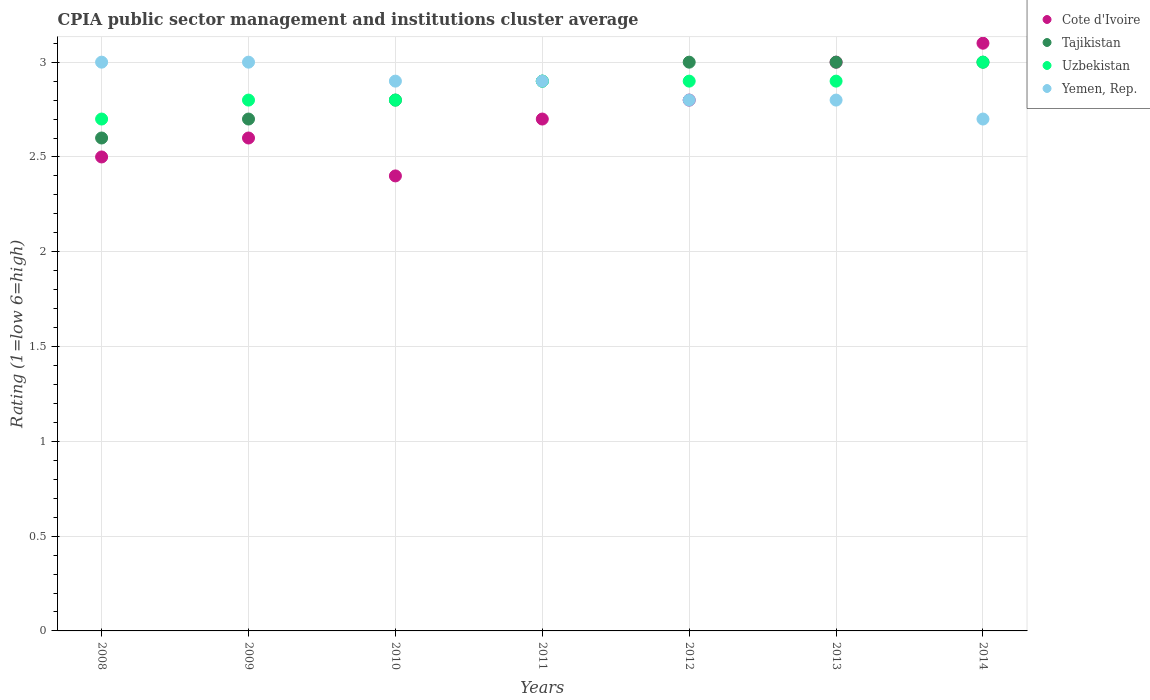How many different coloured dotlines are there?
Your answer should be compact. 4. What is the total CPIA rating in Cote d'Ivoire in the graph?
Provide a succinct answer. 19.1. What is the difference between the CPIA rating in Cote d'Ivoire in 2010 and that in 2013?
Your answer should be very brief. -0.6. What is the difference between the CPIA rating in Cote d'Ivoire in 2008 and the CPIA rating in Uzbekistan in 2010?
Your answer should be very brief. -0.3. What is the average CPIA rating in Uzbekistan per year?
Provide a succinct answer. 2.86. In the year 2010, what is the difference between the CPIA rating in Yemen, Rep. and CPIA rating in Tajikistan?
Your answer should be very brief. 0.1. In how many years, is the CPIA rating in Cote d'Ivoire greater than 1.1?
Provide a succinct answer. 7. What is the ratio of the CPIA rating in Tajikistan in 2008 to that in 2014?
Your response must be concise. 0.87. Is the difference between the CPIA rating in Yemen, Rep. in 2011 and 2012 greater than the difference between the CPIA rating in Tajikistan in 2011 and 2012?
Keep it short and to the point. Yes. What is the difference between the highest and the lowest CPIA rating in Uzbekistan?
Ensure brevity in your answer.  0.3. Is it the case that in every year, the sum of the CPIA rating in Tajikistan and CPIA rating in Yemen, Rep.  is greater than the sum of CPIA rating in Cote d'Ivoire and CPIA rating in Uzbekistan?
Ensure brevity in your answer.  No. Does the CPIA rating in Cote d'Ivoire monotonically increase over the years?
Ensure brevity in your answer.  No. Are the values on the major ticks of Y-axis written in scientific E-notation?
Provide a short and direct response. No. Does the graph contain grids?
Offer a terse response. Yes. How many legend labels are there?
Keep it short and to the point. 4. How are the legend labels stacked?
Provide a succinct answer. Vertical. What is the title of the graph?
Ensure brevity in your answer.  CPIA public sector management and institutions cluster average. What is the label or title of the X-axis?
Keep it short and to the point. Years. What is the label or title of the Y-axis?
Provide a short and direct response. Rating (1=low 6=high). What is the Rating (1=low 6=high) in Tajikistan in 2008?
Your answer should be compact. 2.6. What is the Rating (1=low 6=high) of Uzbekistan in 2008?
Keep it short and to the point. 2.7. What is the Rating (1=low 6=high) of Yemen, Rep. in 2008?
Give a very brief answer. 3. What is the Rating (1=low 6=high) in Tajikistan in 2009?
Provide a succinct answer. 2.7. What is the Rating (1=low 6=high) in Uzbekistan in 2009?
Keep it short and to the point. 2.8. What is the Rating (1=low 6=high) of Cote d'Ivoire in 2010?
Offer a terse response. 2.4. What is the Rating (1=low 6=high) in Uzbekistan in 2010?
Your answer should be compact. 2.8. What is the Rating (1=low 6=high) of Yemen, Rep. in 2010?
Your answer should be very brief. 2.9. What is the Rating (1=low 6=high) of Tajikistan in 2011?
Your answer should be very brief. 2.9. What is the Rating (1=low 6=high) of Uzbekistan in 2011?
Your answer should be very brief. 2.9. What is the Rating (1=low 6=high) in Yemen, Rep. in 2011?
Give a very brief answer. 2.9. What is the Rating (1=low 6=high) in Cote d'Ivoire in 2013?
Your response must be concise. 3. What is the Rating (1=low 6=high) in Uzbekistan in 2013?
Offer a very short reply. 2.9. What is the Rating (1=low 6=high) in Cote d'Ivoire in 2014?
Make the answer very short. 3.1. What is the Rating (1=low 6=high) in Tajikistan in 2014?
Keep it short and to the point. 3. What is the Rating (1=low 6=high) in Uzbekistan in 2014?
Your answer should be very brief. 3. Across all years, what is the maximum Rating (1=low 6=high) in Uzbekistan?
Ensure brevity in your answer.  3. What is the total Rating (1=low 6=high) in Tajikistan in the graph?
Give a very brief answer. 20. What is the total Rating (1=low 6=high) of Uzbekistan in the graph?
Ensure brevity in your answer.  20. What is the total Rating (1=low 6=high) in Yemen, Rep. in the graph?
Make the answer very short. 20.1. What is the difference between the Rating (1=low 6=high) of Tajikistan in 2008 and that in 2009?
Make the answer very short. -0.1. What is the difference between the Rating (1=low 6=high) in Uzbekistan in 2008 and that in 2009?
Make the answer very short. -0.1. What is the difference between the Rating (1=low 6=high) in Yemen, Rep. in 2008 and that in 2009?
Give a very brief answer. 0. What is the difference between the Rating (1=low 6=high) of Cote d'Ivoire in 2008 and that in 2010?
Your answer should be very brief. 0.1. What is the difference between the Rating (1=low 6=high) of Uzbekistan in 2008 and that in 2010?
Provide a short and direct response. -0.1. What is the difference between the Rating (1=low 6=high) in Tajikistan in 2008 and that in 2011?
Provide a succinct answer. -0.3. What is the difference between the Rating (1=low 6=high) in Yemen, Rep. in 2008 and that in 2011?
Your answer should be very brief. 0.1. What is the difference between the Rating (1=low 6=high) in Cote d'Ivoire in 2008 and that in 2012?
Offer a terse response. -0.3. What is the difference between the Rating (1=low 6=high) in Tajikistan in 2008 and that in 2012?
Provide a succinct answer. -0.4. What is the difference between the Rating (1=low 6=high) of Uzbekistan in 2008 and that in 2012?
Keep it short and to the point. -0.2. What is the difference between the Rating (1=low 6=high) in Yemen, Rep. in 2008 and that in 2012?
Provide a succinct answer. 0.2. What is the difference between the Rating (1=low 6=high) in Cote d'Ivoire in 2008 and that in 2013?
Keep it short and to the point. -0.5. What is the difference between the Rating (1=low 6=high) of Uzbekistan in 2008 and that in 2013?
Offer a very short reply. -0.2. What is the difference between the Rating (1=low 6=high) of Yemen, Rep. in 2008 and that in 2013?
Your answer should be very brief. 0.2. What is the difference between the Rating (1=low 6=high) of Uzbekistan in 2008 and that in 2014?
Provide a succinct answer. -0.3. What is the difference between the Rating (1=low 6=high) of Yemen, Rep. in 2008 and that in 2014?
Provide a succinct answer. 0.3. What is the difference between the Rating (1=low 6=high) in Uzbekistan in 2009 and that in 2011?
Your answer should be very brief. -0.1. What is the difference between the Rating (1=low 6=high) in Yemen, Rep. in 2009 and that in 2011?
Keep it short and to the point. 0.1. What is the difference between the Rating (1=low 6=high) in Tajikistan in 2009 and that in 2012?
Your answer should be very brief. -0.3. What is the difference between the Rating (1=low 6=high) of Cote d'Ivoire in 2009 and that in 2014?
Provide a short and direct response. -0.5. What is the difference between the Rating (1=low 6=high) of Uzbekistan in 2009 and that in 2014?
Provide a short and direct response. -0.2. What is the difference between the Rating (1=low 6=high) of Tajikistan in 2010 and that in 2011?
Keep it short and to the point. -0.1. What is the difference between the Rating (1=low 6=high) in Yemen, Rep. in 2010 and that in 2011?
Offer a terse response. 0. What is the difference between the Rating (1=low 6=high) in Cote d'Ivoire in 2010 and that in 2012?
Your answer should be very brief. -0.4. What is the difference between the Rating (1=low 6=high) in Uzbekistan in 2010 and that in 2012?
Provide a succinct answer. -0.1. What is the difference between the Rating (1=low 6=high) of Uzbekistan in 2010 and that in 2013?
Your answer should be compact. -0.1. What is the difference between the Rating (1=low 6=high) of Yemen, Rep. in 2010 and that in 2013?
Give a very brief answer. 0.1. What is the difference between the Rating (1=low 6=high) in Cote d'Ivoire in 2010 and that in 2014?
Your answer should be very brief. -0.7. What is the difference between the Rating (1=low 6=high) of Tajikistan in 2010 and that in 2014?
Your response must be concise. -0.2. What is the difference between the Rating (1=low 6=high) of Uzbekistan in 2010 and that in 2014?
Make the answer very short. -0.2. What is the difference between the Rating (1=low 6=high) in Yemen, Rep. in 2010 and that in 2014?
Your response must be concise. 0.2. What is the difference between the Rating (1=low 6=high) in Cote d'Ivoire in 2011 and that in 2012?
Your answer should be compact. -0.1. What is the difference between the Rating (1=low 6=high) in Tajikistan in 2011 and that in 2012?
Offer a terse response. -0.1. What is the difference between the Rating (1=low 6=high) of Uzbekistan in 2011 and that in 2012?
Give a very brief answer. 0. What is the difference between the Rating (1=low 6=high) in Yemen, Rep. in 2011 and that in 2012?
Your answer should be compact. 0.1. What is the difference between the Rating (1=low 6=high) of Uzbekistan in 2011 and that in 2013?
Your answer should be compact. 0. What is the difference between the Rating (1=low 6=high) of Yemen, Rep. in 2011 and that in 2013?
Provide a succinct answer. 0.1. What is the difference between the Rating (1=low 6=high) of Tajikistan in 2011 and that in 2014?
Provide a short and direct response. -0.1. What is the difference between the Rating (1=low 6=high) of Uzbekistan in 2011 and that in 2014?
Your response must be concise. -0.1. What is the difference between the Rating (1=low 6=high) of Yemen, Rep. in 2011 and that in 2014?
Ensure brevity in your answer.  0.2. What is the difference between the Rating (1=low 6=high) of Yemen, Rep. in 2012 and that in 2013?
Make the answer very short. 0. What is the difference between the Rating (1=low 6=high) in Yemen, Rep. in 2012 and that in 2014?
Your answer should be very brief. 0.1. What is the difference between the Rating (1=low 6=high) in Yemen, Rep. in 2013 and that in 2014?
Make the answer very short. 0.1. What is the difference between the Rating (1=low 6=high) in Cote d'Ivoire in 2008 and the Rating (1=low 6=high) in Uzbekistan in 2009?
Ensure brevity in your answer.  -0.3. What is the difference between the Rating (1=low 6=high) in Cote d'Ivoire in 2008 and the Rating (1=low 6=high) in Yemen, Rep. in 2009?
Your answer should be compact. -0.5. What is the difference between the Rating (1=low 6=high) of Tajikistan in 2008 and the Rating (1=low 6=high) of Uzbekistan in 2009?
Offer a terse response. -0.2. What is the difference between the Rating (1=low 6=high) in Cote d'Ivoire in 2008 and the Rating (1=low 6=high) in Uzbekistan in 2010?
Provide a short and direct response. -0.3. What is the difference between the Rating (1=low 6=high) in Tajikistan in 2008 and the Rating (1=low 6=high) in Uzbekistan in 2010?
Ensure brevity in your answer.  -0.2. What is the difference between the Rating (1=low 6=high) in Uzbekistan in 2008 and the Rating (1=low 6=high) in Yemen, Rep. in 2010?
Your response must be concise. -0.2. What is the difference between the Rating (1=low 6=high) in Cote d'Ivoire in 2008 and the Rating (1=low 6=high) in Yemen, Rep. in 2011?
Your answer should be very brief. -0.4. What is the difference between the Rating (1=low 6=high) in Tajikistan in 2008 and the Rating (1=low 6=high) in Yemen, Rep. in 2011?
Ensure brevity in your answer.  -0.3. What is the difference between the Rating (1=low 6=high) in Uzbekistan in 2008 and the Rating (1=low 6=high) in Yemen, Rep. in 2011?
Offer a very short reply. -0.2. What is the difference between the Rating (1=low 6=high) of Tajikistan in 2008 and the Rating (1=low 6=high) of Uzbekistan in 2012?
Your answer should be compact. -0.3. What is the difference between the Rating (1=low 6=high) of Tajikistan in 2008 and the Rating (1=low 6=high) of Yemen, Rep. in 2012?
Your response must be concise. -0.2. What is the difference between the Rating (1=low 6=high) of Cote d'Ivoire in 2008 and the Rating (1=low 6=high) of Uzbekistan in 2013?
Your answer should be very brief. -0.4. What is the difference between the Rating (1=low 6=high) of Cote d'Ivoire in 2008 and the Rating (1=low 6=high) of Yemen, Rep. in 2013?
Keep it short and to the point. -0.3. What is the difference between the Rating (1=low 6=high) in Tajikistan in 2008 and the Rating (1=low 6=high) in Uzbekistan in 2013?
Give a very brief answer. -0.3. What is the difference between the Rating (1=low 6=high) in Uzbekistan in 2008 and the Rating (1=low 6=high) in Yemen, Rep. in 2013?
Ensure brevity in your answer.  -0.1. What is the difference between the Rating (1=low 6=high) of Tajikistan in 2008 and the Rating (1=low 6=high) of Uzbekistan in 2014?
Offer a very short reply. -0.4. What is the difference between the Rating (1=low 6=high) of Tajikistan in 2008 and the Rating (1=low 6=high) of Yemen, Rep. in 2014?
Provide a short and direct response. -0.1. What is the difference between the Rating (1=low 6=high) of Cote d'Ivoire in 2009 and the Rating (1=low 6=high) of Uzbekistan in 2010?
Ensure brevity in your answer.  -0.2. What is the difference between the Rating (1=low 6=high) in Tajikistan in 2009 and the Rating (1=low 6=high) in Uzbekistan in 2010?
Your answer should be compact. -0.1. What is the difference between the Rating (1=low 6=high) in Cote d'Ivoire in 2009 and the Rating (1=low 6=high) in Uzbekistan in 2011?
Your response must be concise. -0.3. What is the difference between the Rating (1=low 6=high) in Tajikistan in 2009 and the Rating (1=low 6=high) in Uzbekistan in 2011?
Provide a succinct answer. -0.2. What is the difference between the Rating (1=low 6=high) of Cote d'Ivoire in 2009 and the Rating (1=low 6=high) of Tajikistan in 2012?
Ensure brevity in your answer.  -0.4. What is the difference between the Rating (1=low 6=high) of Cote d'Ivoire in 2009 and the Rating (1=low 6=high) of Yemen, Rep. in 2012?
Ensure brevity in your answer.  -0.2. What is the difference between the Rating (1=low 6=high) in Uzbekistan in 2009 and the Rating (1=low 6=high) in Yemen, Rep. in 2012?
Keep it short and to the point. 0. What is the difference between the Rating (1=low 6=high) of Cote d'Ivoire in 2009 and the Rating (1=low 6=high) of Yemen, Rep. in 2013?
Offer a very short reply. -0.2. What is the difference between the Rating (1=low 6=high) of Tajikistan in 2009 and the Rating (1=low 6=high) of Yemen, Rep. in 2013?
Make the answer very short. -0.1. What is the difference between the Rating (1=low 6=high) of Uzbekistan in 2009 and the Rating (1=low 6=high) of Yemen, Rep. in 2013?
Give a very brief answer. 0. What is the difference between the Rating (1=low 6=high) in Tajikistan in 2009 and the Rating (1=low 6=high) in Yemen, Rep. in 2014?
Make the answer very short. 0. What is the difference between the Rating (1=low 6=high) in Uzbekistan in 2009 and the Rating (1=low 6=high) in Yemen, Rep. in 2014?
Give a very brief answer. 0.1. What is the difference between the Rating (1=low 6=high) in Cote d'Ivoire in 2010 and the Rating (1=low 6=high) in Yemen, Rep. in 2011?
Keep it short and to the point. -0.5. What is the difference between the Rating (1=low 6=high) of Tajikistan in 2010 and the Rating (1=low 6=high) of Uzbekistan in 2011?
Your answer should be very brief. -0.1. What is the difference between the Rating (1=low 6=high) of Tajikistan in 2010 and the Rating (1=low 6=high) of Yemen, Rep. in 2011?
Offer a very short reply. -0.1. What is the difference between the Rating (1=low 6=high) in Cote d'Ivoire in 2010 and the Rating (1=low 6=high) in Tajikistan in 2012?
Offer a terse response. -0.6. What is the difference between the Rating (1=low 6=high) of Cote d'Ivoire in 2010 and the Rating (1=low 6=high) of Yemen, Rep. in 2012?
Your answer should be compact. -0.4. What is the difference between the Rating (1=low 6=high) in Tajikistan in 2010 and the Rating (1=low 6=high) in Yemen, Rep. in 2012?
Provide a succinct answer. 0. What is the difference between the Rating (1=low 6=high) of Cote d'Ivoire in 2010 and the Rating (1=low 6=high) of Uzbekistan in 2013?
Keep it short and to the point. -0.5. What is the difference between the Rating (1=low 6=high) in Cote d'Ivoire in 2010 and the Rating (1=low 6=high) in Yemen, Rep. in 2013?
Ensure brevity in your answer.  -0.4. What is the difference between the Rating (1=low 6=high) of Tajikistan in 2010 and the Rating (1=low 6=high) of Uzbekistan in 2013?
Offer a terse response. -0.1. What is the difference between the Rating (1=low 6=high) of Cote d'Ivoire in 2010 and the Rating (1=low 6=high) of Uzbekistan in 2014?
Your response must be concise. -0.6. What is the difference between the Rating (1=low 6=high) in Cote d'Ivoire in 2010 and the Rating (1=low 6=high) in Yemen, Rep. in 2014?
Provide a short and direct response. -0.3. What is the difference between the Rating (1=low 6=high) in Uzbekistan in 2010 and the Rating (1=low 6=high) in Yemen, Rep. in 2014?
Provide a short and direct response. 0.1. What is the difference between the Rating (1=low 6=high) in Cote d'Ivoire in 2011 and the Rating (1=low 6=high) in Tajikistan in 2012?
Your response must be concise. -0.3. What is the difference between the Rating (1=low 6=high) of Cote d'Ivoire in 2011 and the Rating (1=low 6=high) of Uzbekistan in 2012?
Your response must be concise. -0.2. What is the difference between the Rating (1=low 6=high) in Cote d'Ivoire in 2011 and the Rating (1=low 6=high) in Yemen, Rep. in 2012?
Provide a succinct answer. -0.1. What is the difference between the Rating (1=low 6=high) of Tajikistan in 2011 and the Rating (1=low 6=high) of Yemen, Rep. in 2012?
Your response must be concise. 0.1. What is the difference between the Rating (1=low 6=high) of Cote d'Ivoire in 2011 and the Rating (1=low 6=high) of Tajikistan in 2013?
Provide a succinct answer. -0.3. What is the difference between the Rating (1=low 6=high) in Cote d'Ivoire in 2011 and the Rating (1=low 6=high) in Uzbekistan in 2013?
Your answer should be compact. -0.2. What is the difference between the Rating (1=low 6=high) of Cote d'Ivoire in 2011 and the Rating (1=low 6=high) of Yemen, Rep. in 2013?
Your response must be concise. -0.1. What is the difference between the Rating (1=low 6=high) of Tajikistan in 2011 and the Rating (1=low 6=high) of Yemen, Rep. in 2013?
Ensure brevity in your answer.  0.1. What is the difference between the Rating (1=low 6=high) of Uzbekistan in 2011 and the Rating (1=low 6=high) of Yemen, Rep. in 2013?
Give a very brief answer. 0.1. What is the difference between the Rating (1=low 6=high) in Cote d'Ivoire in 2011 and the Rating (1=low 6=high) in Tajikistan in 2014?
Make the answer very short. -0.3. What is the difference between the Rating (1=low 6=high) of Cote d'Ivoire in 2011 and the Rating (1=low 6=high) of Uzbekistan in 2014?
Provide a succinct answer. -0.3. What is the difference between the Rating (1=low 6=high) of Uzbekistan in 2011 and the Rating (1=low 6=high) of Yemen, Rep. in 2014?
Offer a very short reply. 0.2. What is the difference between the Rating (1=low 6=high) of Cote d'Ivoire in 2012 and the Rating (1=low 6=high) of Tajikistan in 2013?
Offer a very short reply. -0.2. What is the difference between the Rating (1=low 6=high) of Cote d'Ivoire in 2012 and the Rating (1=low 6=high) of Uzbekistan in 2013?
Give a very brief answer. -0.1. What is the difference between the Rating (1=low 6=high) in Uzbekistan in 2012 and the Rating (1=low 6=high) in Yemen, Rep. in 2013?
Your response must be concise. 0.1. What is the difference between the Rating (1=low 6=high) of Cote d'Ivoire in 2012 and the Rating (1=low 6=high) of Uzbekistan in 2014?
Provide a succinct answer. -0.2. What is the difference between the Rating (1=low 6=high) in Cote d'Ivoire in 2012 and the Rating (1=low 6=high) in Yemen, Rep. in 2014?
Offer a very short reply. 0.1. What is the difference between the Rating (1=low 6=high) of Tajikistan in 2012 and the Rating (1=low 6=high) of Yemen, Rep. in 2014?
Your response must be concise. 0.3. What is the difference between the Rating (1=low 6=high) in Uzbekistan in 2012 and the Rating (1=low 6=high) in Yemen, Rep. in 2014?
Your answer should be very brief. 0.2. What is the difference between the Rating (1=low 6=high) in Tajikistan in 2013 and the Rating (1=low 6=high) in Yemen, Rep. in 2014?
Make the answer very short. 0.3. What is the average Rating (1=low 6=high) of Cote d'Ivoire per year?
Your answer should be very brief. 2.73. What is the average Rating (1=low 6=high) in Tajikistan per year?
Your response must be concise. 2.86. What is the average Rating (1=low 6=high) in Uzbekistan per year?
Keep it short and to the point. 2.86. What is the average Rating (1=low 6=high) of Yemen, Rep. per year?
Offer a terse response. 2.87. In the year 2008, what is the difference between the Rating (1=low 6=high) in Cote d'Ivoire and Rating (1=low 6=high) in Tajikistan?
Your response must be concise. -0.1. In the year 2008, what is the difference between the Rating (1=low 6=high) in Cote d'Ivoire and Rating (1=low 6=high) in Yemen, Rep.?
Your response must be concise. -0.5. In the year 2008, what is the difference between the Rating (1=low 6=high) in Tajikistan and Rating (1=low 6=high) in Uzbekistan?
Make the answer very short. -0.1. In the year 2008, what is the difference between the Rating (1=low 6=high) in Tajikistan and Rating (1=low 6=high) in Yemen, Rep.?
Your answer should be very brief. -0.4. In the year 2009, what is the difference between the Rating (1=low 6=high) of Tajikistan and Rating (1=low 6=high) of Uzbekistan?
Keep it short and to the point. -0.1. In the year 2010, what is the difference between the Rating (1=low 6=high) in Cote d'Ivoire and Rating (1=low 6=high) in Tajikistan?
Offer a very short reply. -0.4. In the year 2010, what is the difference between the Rating (1=low 6=high) in Tajikistan and Rating (1=low 6=high) in Yemen, Rep.?
Keep it short and to the point. -0.1. In the year 2011, what is the difference between the Rating (1=low 6=high) of Cote d'Ivoire and Rating (1=low 6=high) of Uzbekistan?
Offer a very short reply. -0.2. In the year 2011, what is the difference between the Rating (1=low 6=high) of Tajikistan and Rating (1=low 6=high) of Uzbekistan?
Your answer should be compact. 0. In the year 2011, what is the difference between the Rating (1=low 6=high) in Uzbekistan and Rating (1=low 6=high) in Yemen, Rep.?
Keep it short and to the point. 0. In the year 2012, what is the difference between the Rating (1=low 6=high) of Cote d'Ivoire and Rating (1=low 6=high) of Tajikistan?
Ensure brevity in your answer.  -0.2. In the year 2012, what is the difference between the Rating (1=low 6=high) of Cote d'Ivoire and Rating (1=low 6=high) of Uzbekistan?
Give a very brief answer. -0.1. In the year 2012, what is the difference between the Rating (1=low 6=high) of Cote d'Ivoire and Rating (1=low 6=high) of Yemen, Rep.?
Provide a short and direct response. 0. In the year 2012, what is the difference between the Rating (1=low 6=high) in Tajikistan and Rating (1=low 6=high) in Uzbekistan?
Your response must be concise. 0.1. In the year 2013, what is the difference between the Rating (1=low 6=high) of Cote d'Ivoire and Rating (1=low 6=high) of Tajikistan?
Keep it short and to the point. 0. In the year 2013, what is the difference between the Rating (1=low 6=high) of Tajikistan and Rating (1=low 6=high) of Yemen, Rep.?
Your response must be concise. 0.2. In the year 2014, what is the difference between the Rating (1=low 6=high) in Cote d'Ivoire and Rating (1=low 6=high) in Tajikistan?
Ensure brevity in your answer.  0.1. In the year 2014, what is the difference between the Rating (1=low 6=high) in Cote d'Ivoire and Rating (1=low 6=high) in Yemen, Rep.?
Provide a short and direct response. 0.4. In the year 2014, what is the difference between the Rating (1=low 6=high) of Uzbekistan and Rating (1=low 6=high) of Yemen, Rep.?
Your response must be concise. 0.3. What is the ratio of the Rating (1=low 6=high) in Cote d'Ivoire in 2008 to that in 2009?
Make the answer very short. 0.96. What is the ratio of the Rating (1=low 6=high) of Tajikistan in 2008 to that in 2009?
Ensure brevity in your answer.  0.96. What is the ratio of the Rating (1=low 6=high) in Uzbekistan in 2008 to that in 2009?
Provide a succinct answer. 0.96. What is the ratio of the Rating (1=low 6=high) in Yemen, Rep. in 2008 to that in 2009?
Your response must be concise. 1. What is the ratio of the Rating (1=low 6=high) of Cote d'Ivoire in 2008 to that in 2010?
Your answer should be compact. 1.04. What is the ratio of the Rating (1=low 6=high) of Tajikistan in 2008 to that in 2010?
Your response must be concise. 0.93. What is the ratio of the Rating (1=low 6=high) in Uzbekistan in 2008 to that in 2010?
Your answer should be compact. 0.96. What is the ratio of the Rating (1=low 6=high) in Yemen, Rep. in 2008 to that in 2010?
Make the answer very short. 1.03. What is the ratio of the Rating (1=low 6=high) of Cote d'Ivoire in 2008 to that in 2011?
Offer a very short reply. 0.93. What is the ratio of the Rating (1=low 6=high) of Tajikistan in 2008 to that in 2011?
Give a very brief answer. 0.9. What is the ratio of the Rating (1=low 6=high) in Yemen, Rep. in 2008 to that in 2011?
Your response must be concise. 1.03. What is the ratio of the Rating (1=low 6=high) of Cote d'Ivoire in 2008 to that in 2012?
Your response must be concise. 0.89. What is the ratio of the Rating (1=low 6=high) of Tajikistan in 2008 to that in 2012?
Your answer should be very brief. 0.87. What is the ratio of the Rating (1=low 6=high) of Yemen, Rep. in 2008 to that in 2012?
Provide a succinct answer. 1.07. What is the ratio of the Rating (1=low 6=high) of Tajikistan in 2008 to that in 2013?
Ensure brevity in your answer.  0.87. What is the ratio of the Rating (1=low 6=high) in Uzbekistan in 2008 to that in 2013?
Offer a terse response. 0.93. What is the ratio of the Rating (1=low 6=high) of Yemen, Rep. in 2008 to that in 2013?
Your response must be concise. 1.07. What is the ratio of the Rating (1=low 6=high) of Cote d'Ivoire in 2008 to that in 2014?
Ensure brevity in your answer.  0.81. What is the ratio of the Rating (1=low 6=high) of Tajikistan in 2008 to that in 2014?
Your response must be concise. 0.87. What is the ratio of the Rating (1=low 6=high) of Uzbekistan in 2008 to that in 2014?
Your answer should be very brief. 0.9. What is the ratio of the Rating (1=low 6=high) in Yemen, Rep. in 2008 to that in 2014?
Give a very brief answer. 1.11. What is the ratio of the Rating (1=low 6=high) of Uzbekistan in 2009 to that in 2010?
Your answer should be very brief. 1. What is the ratio of the Rating (1=low 6=high) in Yemen, Rep. in 2009 to that in 2010?
Offer a terse response. 1.03. What is the ratio of the Rating (1=low 6=high) of Uzbekistan in 2009 to that in 2011?
Your response must be concise. 0.97. What is the ratio of the Rating (1=low 6=high) in Yemen, Rep. in 2009 to that in 2011?
Your response must be concise. 1.03. What is the ratio of the Rating (1=low 6=high) of Cote d'Ivoire in 2009 to that in 2012?
Your response must be concise. 0.93. What is the ratio of the Rating (1=low 6=high) of Uzbekistan in 2009 to that in 2012?
Your answer should be compact. 0.97. What is the ratio of the Rating (1=low 6=high) in Yemen, Rep. in 2009 to that in 2012?
Ensure brevity in your answer.  1.07. What is the ratio of the Rating (1=low 6=high) of Cote d'Ivoire in 2009 to that in 2013?
Your response must be concise. 0.87. What is the ratio of the Rating (1=low 6=high) in Tajikistan in 2009 to that in 2013?
Your answer should be compact. 0.9. What is the ratio of the Rating (1=low 6=high) of Uzbekistan in 2009 to that in 2013?
Offer a very short reply. 0.97. What is the ratio of the Rating (1=low 6=high) of Yemen, Rep. in 2009 to that in 2013?
Ensure brevity in your answer.  1.07. What is the ratio of the Rating (1=low 6=high) in Cote d'Ivoire in 2009 to that in 2014?
Give a very brief answer. 0.84. What is the ratio of the Rating (1=low 6=high) in Cote d'Ivoire in 2010 to that in 2011?
Offer a terse response. 0.89. What is the ratio of the Rating (1=low 6=high) of Tajikistan in 2010 to that in 2011?
Give a very brief answer. 0.97. What is the ratio of the Rating (1=low 6=high) in Uzbekistan in 2010 to that in 2011?
Your answer should be compact. 0.97. What is the ratio of the Rating (1=low 6=high) in Cote d'Ivoire in 2010 to that in 2012?
Provide a succinct answer. 0.86. What is the ratio of the Rating (1=low 6=high) of Uzbekistan in 2010 to that in 2012?
Offer a very short reply. 0.97. What is the ratio of the Rating (1=low 6=high) in Yemen, Rep. in 2010 to that in 2012?
Keep it short and to the point. 1.04. What is the ratio of the Rating (1=low 6=high) in Tajikistan in 2010 to that in 2013?
Offer a very short reply. 0.93. What is the ratio of the Rating (1=low 6=high) of Uzbekistan in 2010 to that in 2013?
Your answer should be very brief. 0.97. What is the ratio of the Rating (1=low 6=high) of Yemen, Rep. in 2010 to that in 2013?
Offer a terse response. 1.04. What is the ratio of the Rating (1=low 6=high) in Cote d'Ivoire in 2010 to that in 2014?
Offer a very short reply. 0.77. What is the ratio of the Rating (1=low 6=high) of Tajikistan in 2010 to that in 2014?
Offer a very short reply. 0.93. What is the ratio of the Rating (1=low 6=high) of Uzbekistan in 2010 to that in 2014?
Ensure brevity in your answer.  0.93. What is the ratio of the Rating (1=low 6=high) of Yemen, Rep. in 2010 to that in 2014?
Your answer should be compact. 1.07. What is the ratio of the Rating (1=low 6=high) of Cote d'Ivoire in 2011 to that in 2012?
Provide a short and direct response. 0.96. What is the ratio of the Rating (1=low 6=high) in Tajikistan in 2011 to that in 2012?
Your answer should be very brief. 0.97. What is the ratio of the Rating (1=low 6=high) in Uzbekistan in 2011 to that in 2012?
Provide a succinct answer. 1. What is the ratio of the Rating (1=low 6=high) in Yemen, Rep. in 2011 to that in 2012?
Provide a succinct answer. 1.04. What is the ratio of the Rating (1=low 6=high) in Tajikistan in 2011 to that in 2013?
Your response must be concise. 0.97. What is the ratio of the Rating (1=low 6=high) of Yemen, Rep. in 2011 to that in 2013?
Keep it short and to the point. 1.04. What is the ratio of the Rating (1=low 6=high) of Cote d'Ivoire in 2011 to that in 2014?
Offer a very short reply. 0.87. What is the ratio of the Rating (1=low 6=high) of Tajikistan in 2011 to that in 2014?
Ensure brevity in your answer.  0.97. What is the ratio of the Rating (1=low 6=high) of Uzbekistan in 2011 to that in 2014?
Your response must be concise. 0.97. What is the ratio of the Rating (1=low 6=high) of Yemen, Rep. in 2011 to that in 2014?
Make the answer very short. 1.07. What is the ratio of the Rating (1=low 6=high) of Uzbekistan in 2012 to that in 2013?
Offer a very short reply. 1. What is the ratio of the Rating (1=low 6=high) in Yemen, Rep. in 2012 to that in 2013?
Make the answer very short. 1. What is the ratio of the Rating (1=low 6=high) of Cote d'Ivoire in 2012 to that in 2014?
Make the answer very short. 0.9. What is the ratio of the Rating (1=low 6=high) of Uzbekistan in 2012 to that in 2014?
Make the answer very short. 0.97. What is the ratio of the Rating (1=low 6=high) of Cote d'Ivoire in 2013 to that in 2014?
Keep it short and to the point. 0.97. What is the ratio of the Rating (1=low 6=high) in Uzbekistan in 2013 to that in 2014?
Keep it short and to the point. 0.97. What is the difference between the highest and the second highest Rating (1=low 6=high) of Tajikistan?
Make the answer very short. 0. What is the difference between the highest and the second highest Rating (1=low 6=high) in Uzbekistan?
Ensure brevity in your answer.  0.1. What is the difference between the highest and the second highest Rating (1=low 6=high) in Yemen, Rep.?
Provide a succinct answer. 0. What is the difference between the highest and the lowest Rating (1=low 6=high) in Cote d'Ivoire?
Offer a very short reply. 0.7. What is the difference between the highest and the lowest Rating (1=low 6=high) in Tajikistan?
Your answer should be compact. 0.4. What is the difference between the highest and the lowest Rating (1=low 6=high) in Uzbekistan?
Provide a short and direct response. 0.3. What is the difference between the highest and the lowest Rating (1=low 6=high) of Yemen, Rep.?
Your answer should be very brief. 0.3. 